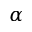Convert formula to latex. <formula><loc_0><loc_0><loc_500><loc_500>\alpha</formula> 